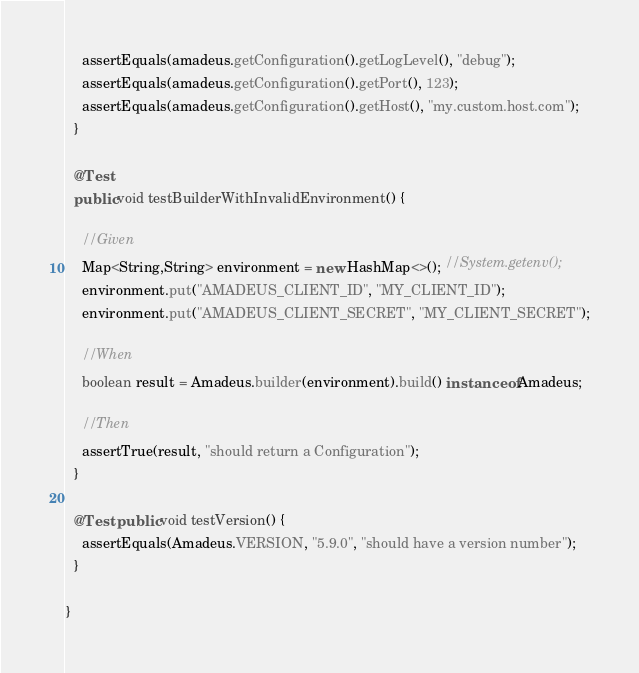<code> <loc_0><loc_0><loc_500><loc_500><_Java_>    assertEquals(amadeus.getConfiguration().getLogLevel(), "debug");
    assertEquals(amadeus.getConfiguration().getPort(), 123);
    assertEquals(amadeus.getConfiguration().getHost(), "my.custom.host.com");
  }

  @Test
  public void testBuilderWithInvalidEnvironment() {

    //Given
    Map<String,String> environment = new HashMap<>(); //System.getenv();
    environment.put("AMADEUS_CLIENT_ID", "MY_CLIENT_ID");
    environment.put("AMADEUS_CLIENT_SECRET", "MY_CLIENT_SECRET");

    //When
    boolean result = Amadeus.builder(environment).build() instanceof Amadeus;

    //Then
    assertTrue(result, "should return a Configuration");
  }

  @Test public void testVersion() {
    assertEquals(Amadeus.VERSION, "5.9.0", "should have a version number");
  }

}
</code> 